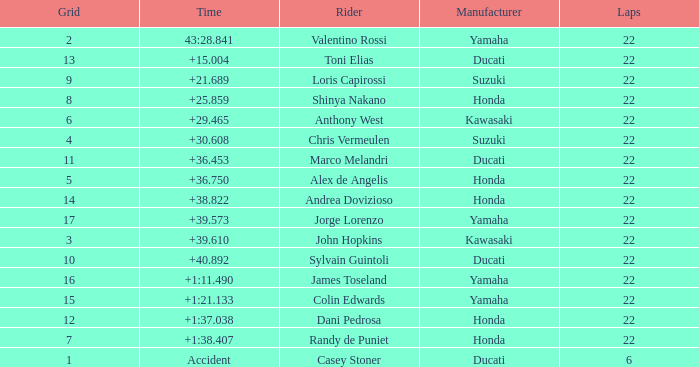What is honda's top grid position with a time of +1:3 7.0. 